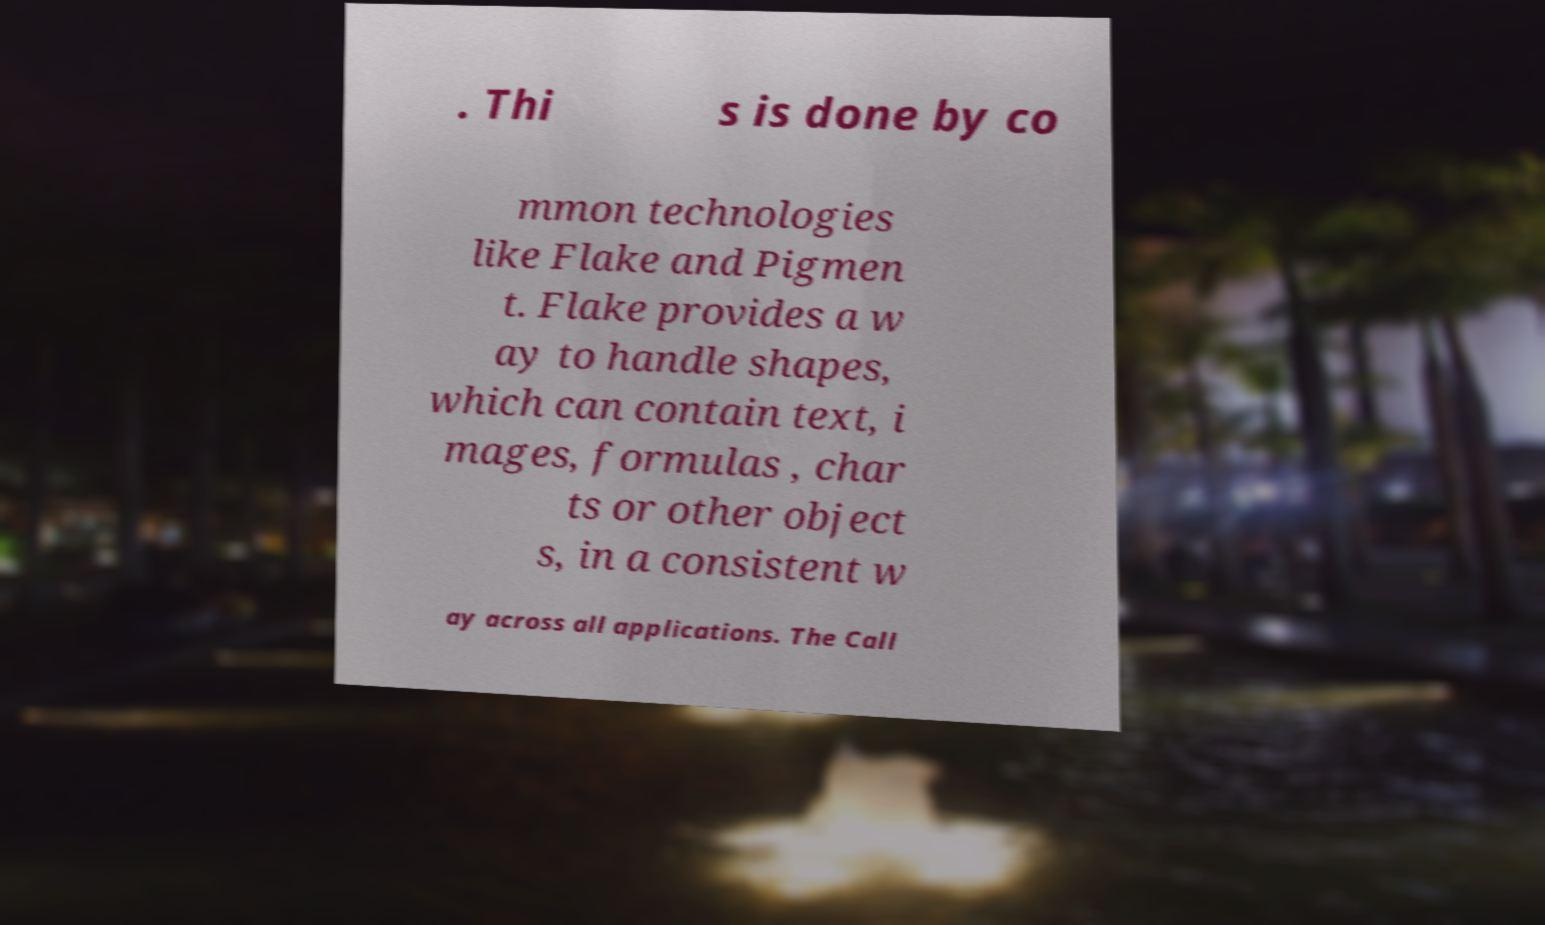Can you accurately transcribe the text from the provided image for me? . Thi s is done by co mmon technologies like Flake and Pigmen t. Flake provides a w ay to handle shapes, which can contain text, i mages, formulas , char ts or other object s, in a consistent w ay across all applications. The Call 